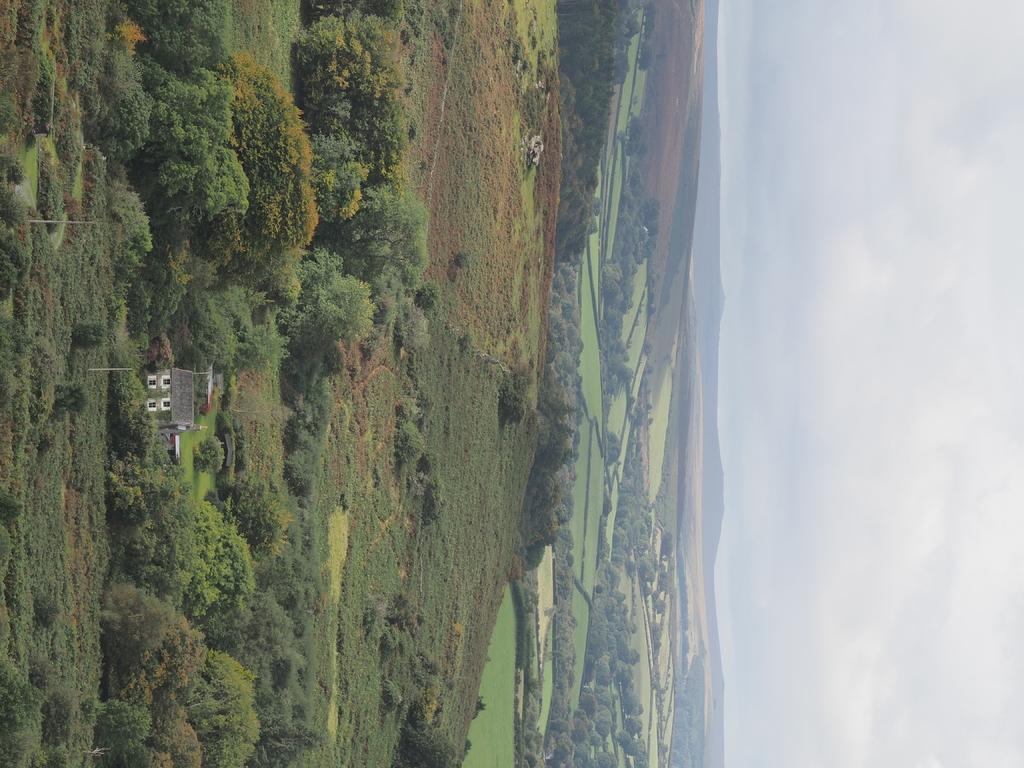How would you summarize this image in a sentence or two? In this picture we can see grass, plants and trees, there is a house on the left side, we can see the sky on the right side of the picture. 